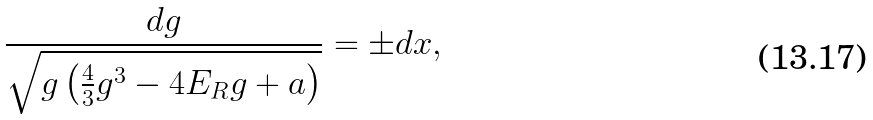Convert formula to latex. <formula><loc_0><loc_0><loc_500><loc_500>\frac { d g } { \sqrt { g \left ( \frac { 4 } { 3 } g ^ { 3 } - 4 E _ { R } g + a \right ) } } = \pm d x ,</formula> 